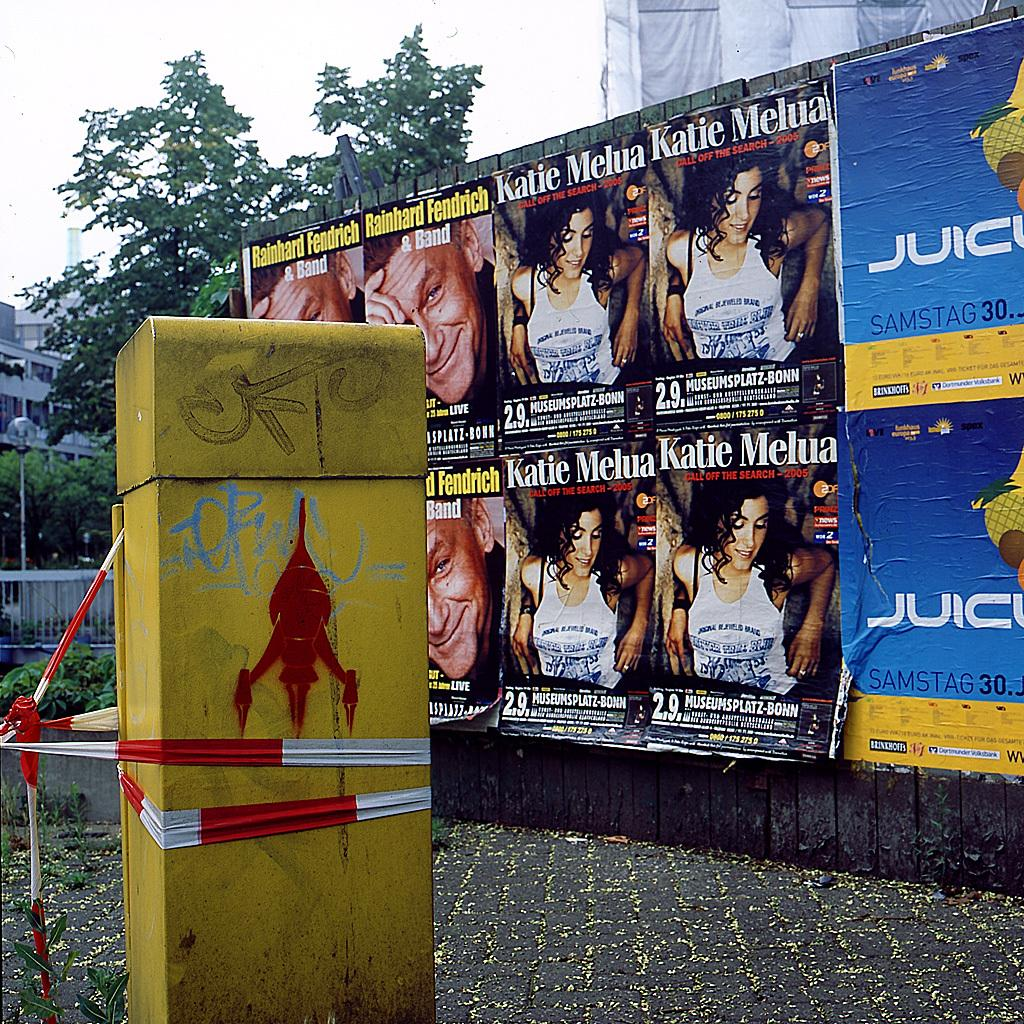<image>
Describe the image concisely. A wall of advertising featuring Katie Melua and Rainhard Fendrich. 